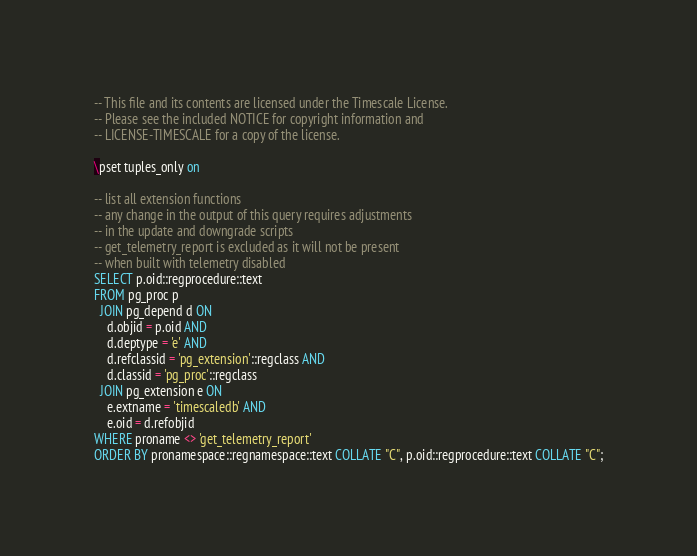<code> <loc_0><loc_0><loc_500><loc_500><_SQL_>-- This file and its contents are licensed under the Timescale License.
-- Please see the included NOTICE for copyright information and
-- LICENSE-TIMESCALE for a copy of the license.

\pset tuples_only on

-- list all extension functions
-- any change in the output of this query requires adjustments
-- in the update and downgrade scripts
-- get_telemetry_report is excluded as it will not be present
-- when built with telemetry disabled
SELECT p.oid::regprocedure::text
FROM pg_proc p
  JOIN pg_depend d ON
    d.objid = p.oid AND
    d.deptype = 'e' AND
    d.refclassid = 'pg_extension'::regclass AND
    d.classid = 'pg_proc'::regclass
  JOIN pg_extension e ON
    e.extname = 'timescaledb' AND
    e.oid = d.refobjid
WHERE proname <> 'get_telemetry_report'
ORDER BY pronamespace::regnamespace::text COLLATE "C", p.oid::regprocedure::text COLLATE "C";
</code> 